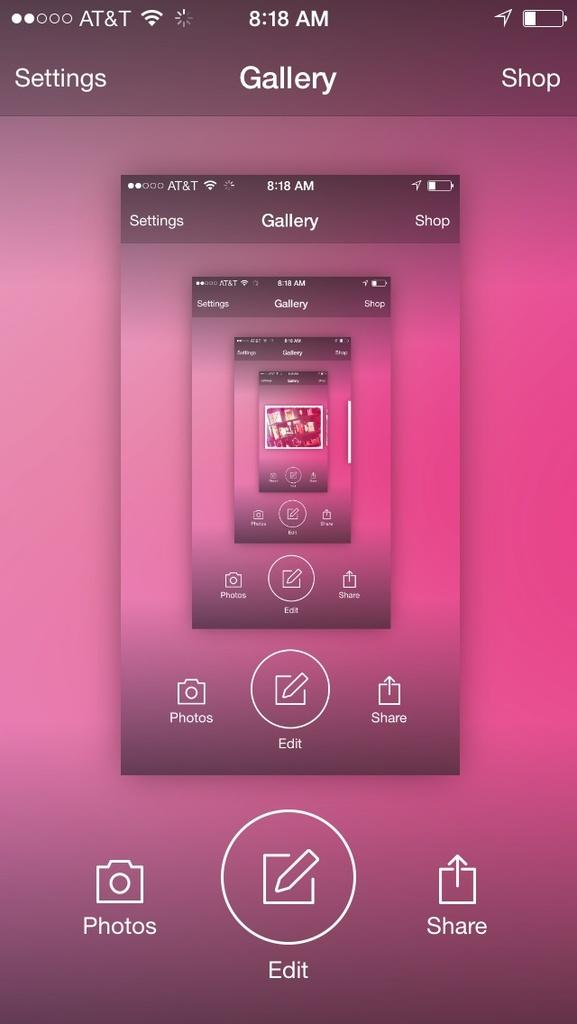<image>
Relay a brief, clear account of the picture shown. The purple screen has a shop button on the top right. 